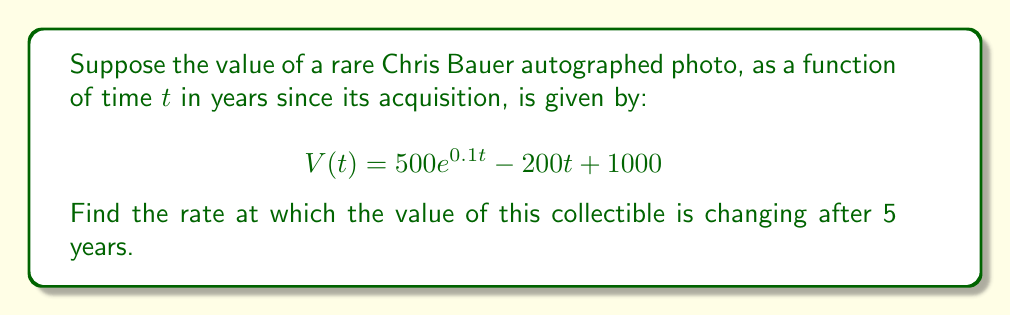Can you solve this math problem? To find the rate at which the value is changing after 5 years, we need to:
1) Find the derivative of the function $V(t)$
2) Evaluate the derivative at $t = 5$

Step 1: Finding the derivative of $V(t)$

We use the sum/difference rule and the chain rule:

$$\frac{d}{dt}[V(t)] = \frac{d}{dt}[500e^{0.1t}] - \frac{d}{dt}[200t] + \frac{d}{dt}[1000]$$

$\frac{d}{dt}[500e^{0.1t}] = 500 \cdot 0.1e^{0.1t} = 50e^{0.1t}$
$\frac{d}{dt}[200t] = 200$
$\frac{d}{dt}[1000] = 0$

Therefore, $V'(t) = 50e^{0.1t} - 200$

Step 2: Evaluating $V'(t)$ at $t = 5$

$V'(5) = 50e^{0.1(5)} - 200$
$= 50e^{0.5} - 200$
$\approx 82.44 - 200$
$\approx -117.56$
Answer: $-117.56$ dollars per year 